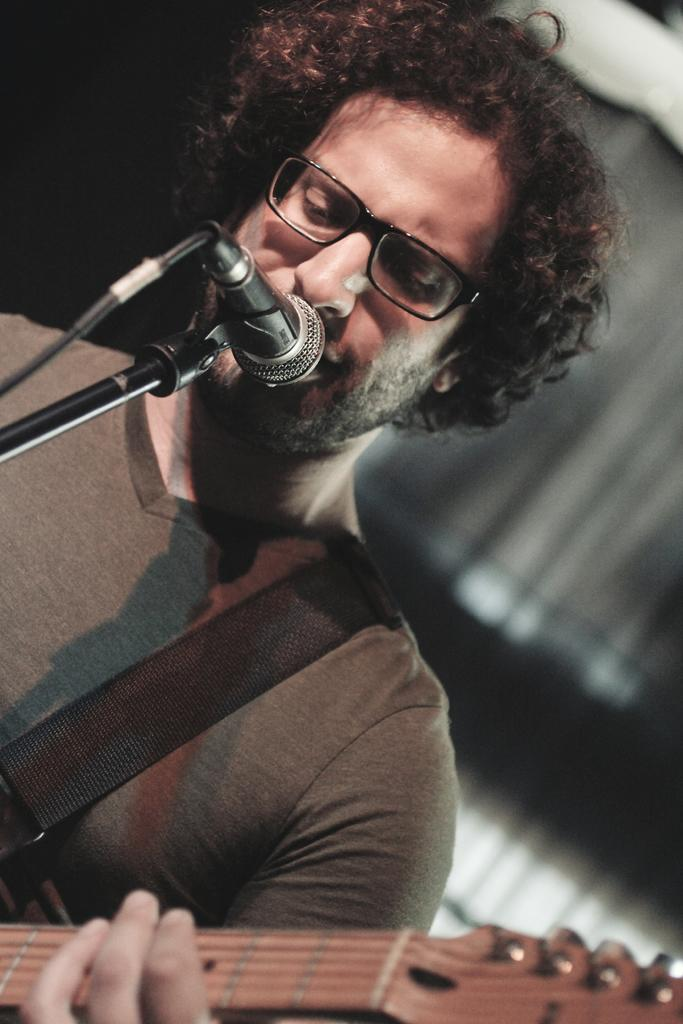Who is the main subject in the image? There is a man in the image. What is the man holding in the image? The man is holding a guitar. What is the man doing in the image? The man is singing. What object is in front of the man? There is a microphone in front of the man. Can you see the tail of the man's friend in the image? There is no friend or tail present in the image. 